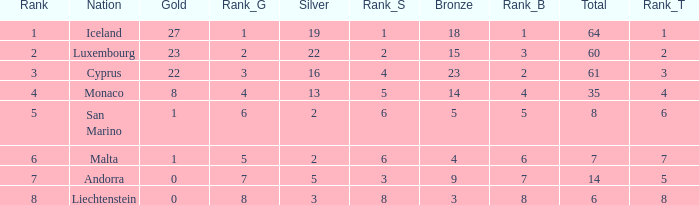How many golds for the nation with 14 total? 0.0. 